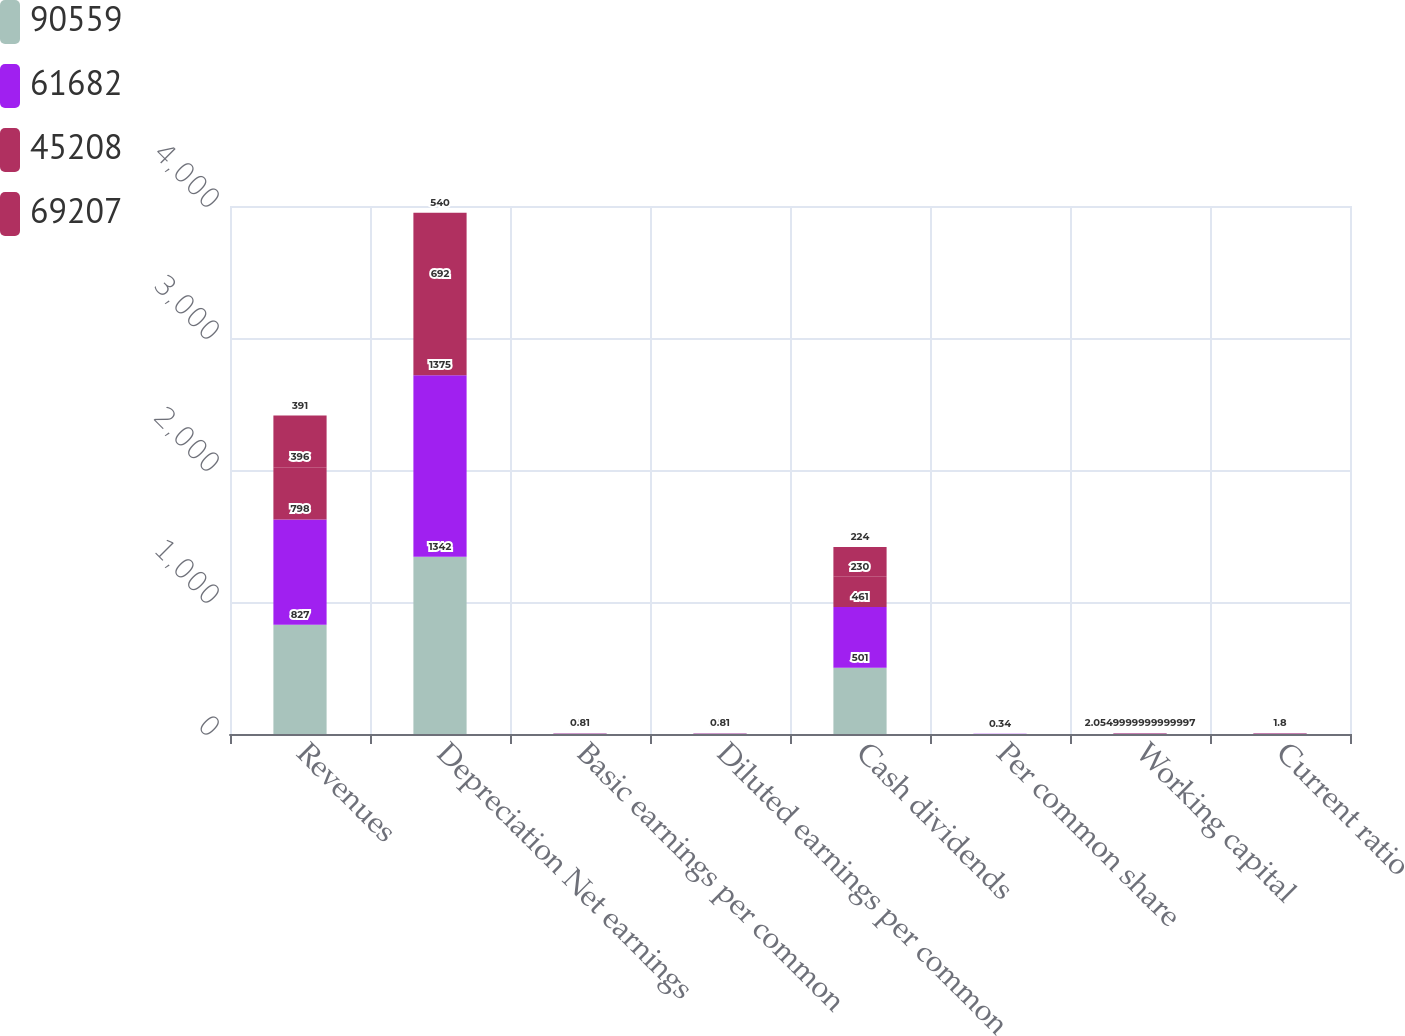<chart> <loc_0><loc_0><loc_500><loc_500><stacked_bar_chart><ecel><fcel>Revenues<fcel>Depreciation Net earnings<fcel>Basic earnings per common<fcel>Diluted earnings per common<fcel>Cash dividends<fcel>Per common share<fcel>Working capital<fcel>Current ratio<nl><fcel>90559<fcel>827<fcel>1342<fcel>2.03<fcel>2.02<fcel>501<fcel>0.76<fcel>2.055<fcel>1.8<nl><fcel>61682<fcel>798<fcel>1375<fcel>2.08<fcel>2.08<fcel>461<fcel>0.7<fcel>2.055<fcel>1.8<nl><fcel>45208<fcel>396<fcel>692<fcel>1.05<fcel>1.05<fcel>230<fcel>0.35<fcel>2.055<fcel>1.8<nl><fcel>69207<fcel>391<fcel>540<fcel>0.81<fcel>0.81<fcel>224<fcel>0.34<fcel>2.055<fcel>1.8<nl></chart> 